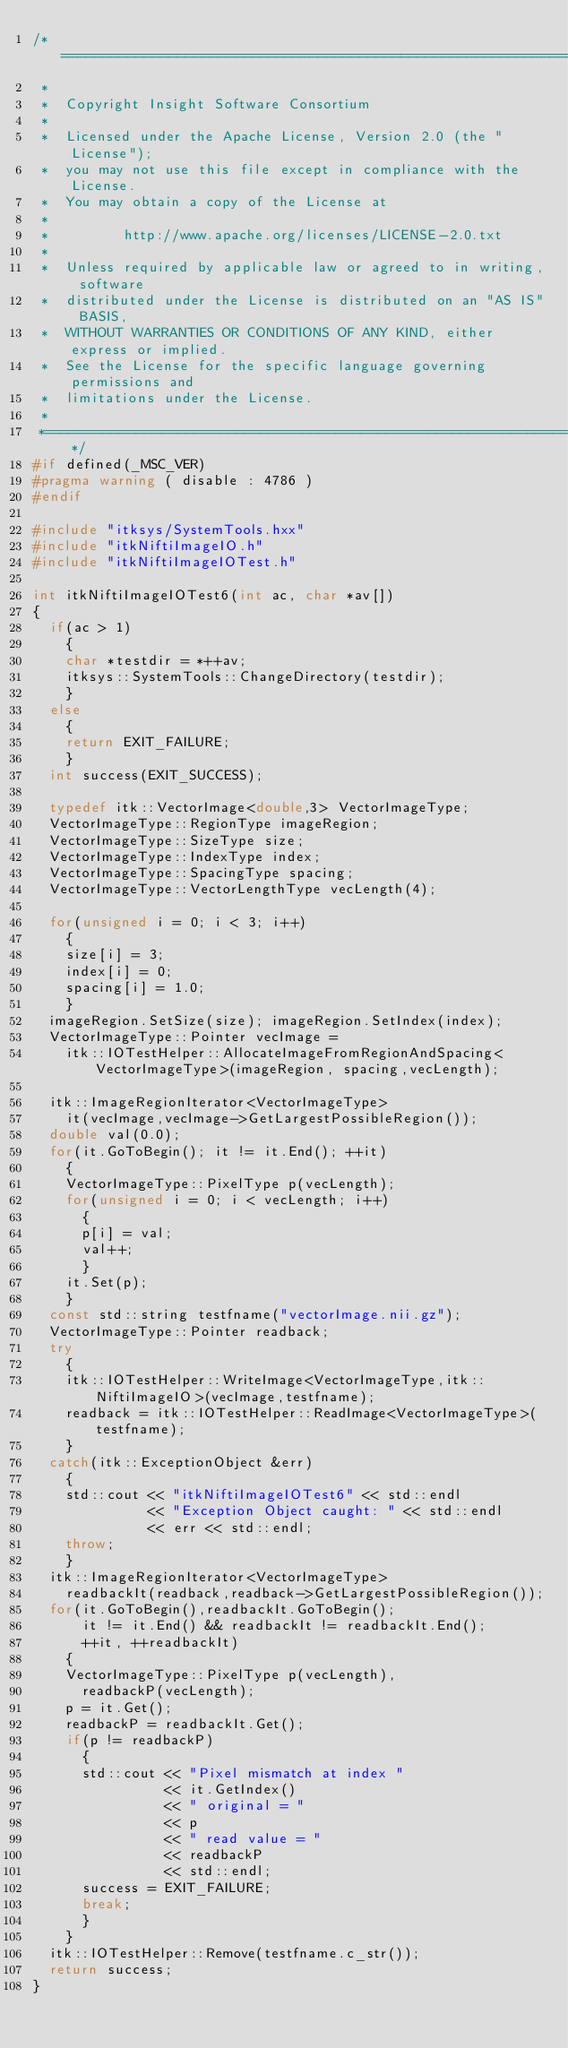Convert code to text. <code><loc_0><loc_0><loc_500><loc_500><_C++_>/*=========================================================================
 *
 *  Copyright Insight Software Consortium
 *
 *  Licensed under the Apache License, Version 2.0 (the "License");
 *  you may not use this file except in compliance with the License.
 *  You may obtain a copy of the License at
 *
 *         http://www.apache.org/licenses/LICENSE-2.0.txt
 *
 *  Unless required by applicable law or agreed to in writing, software
 *  distributed under the License is distributed on an "AS IS" BASIS,
 *  WITHOUT WARRANTIES OR CONDITIONS OF ANY KIND, either express or implied.
 *  See the License for the specific language governing permissions and
 *  limitations under the License.
 *
 *=========================================================================*/
#if defined(_MSC_VER)
#pragma warning ( disable : 4786 )
#endif

#include "itksys/SystemTools.hxx"
#include "itkNiftiImageIO.h"
#include "itkNiftiImageIOTest.h"

int itkNiftiImageIOTest6(int ac, char *av[])
{
  if(ac > 1)
    {
    char *testdir = *++av;
    itksys::SystemTools::ChangeDirectory(testdir);
    }
  else
    {
    return EXIT_FAILURE;
    }
  int success(EXIT_SUCCESS);

  typedef itk::VectorImage<double,3> VectorImageType;
  VectorImageType::RegionType imageRegion;
  VectorImageType::SizeType size;
  VectorImageType::IndexType index;
  VectorImageType::SpacingType spacing;
  VectorImageType::VectorLengthType vecLength(4);

  for(unsigned i = 0; i < 3; i++)
    {
    size[i] = 3;
    index[i] = 0;
    spacing[i] = 1.0;
    }
  imageRegion.SetSize(size); imageRegion.SetIndex(index);
  VectorImageType::Pointer vecImage =
    itk::IOTestHelper::AllocateImageFromRegionAndSpacing<VectorImageType>(imageRegion, spacing,vecLength);

  itk::ImageRegionIterator<VectorImageType>
    it(vecImage,vecImage->GetLargestPossibleRegion());
  double val(0.0);
  for(it.GoToBegin(); it != it.End(); ++it)
    {
    VectorImageType::PixelType p(vecLength);
    for(unsigned i = 0; i < vecLength; i++)
      {
      p[i] = val;
      val++;
      }
    it.Set(p);
    }
  const std::string testfname("vectorImage.nii.gz");
  VectorImageType::Pointer readback;
  try
    {
    itk::IOTestHelper::WriteImage<VectorImageType,itk::NiftiImageIO>(vecImage,testfname);
    readback = itk::IOTestHelper::ReadImage<VectorImageType>(testfname);
    }
  catch(itk::ExceptionObject &err)
    {
    std::cout << "itkNiftiImageIOTest6" << std::endl
              << "Exception Object caught: " << std::endl
              << err << std::endl;
    throw;
    }
  itk::ImageRegionIterator<VectorImageType>
    readbackIt(readback,readback->GetLargestPossibleRegion());
  for(it.GoToBegin(),readbackIt.GoToBegin();
      it != it.End() && readbackIt != readbackIt.End();
      ++it, ++readbackIt)
    {
    VectorImageType::PixelType p(vecLength),
      readbackP(vecLength);
    p = it.Get();
    readbackP = readbackIt.Get();
    if(p != readbackP)
      {
      std::cout << "Pixel mismatch at index "
                << it.GetIndex()
                << " original = "
                << p
                << " read value = "
                << readbackP
                << std::endl;
      success = EXIT_FAILURE;
      break;
      }
    }
  itk::IOTestHelper::Remove(testfname.c_str());
  return success;
}
</code> 